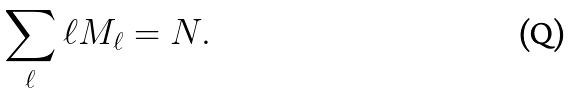Convert formula to latex. <formula><loc_0><loc_0><loc_500><loc_500>\sum _ { \ell } \ell M _ { \ell } = N .</formula> 